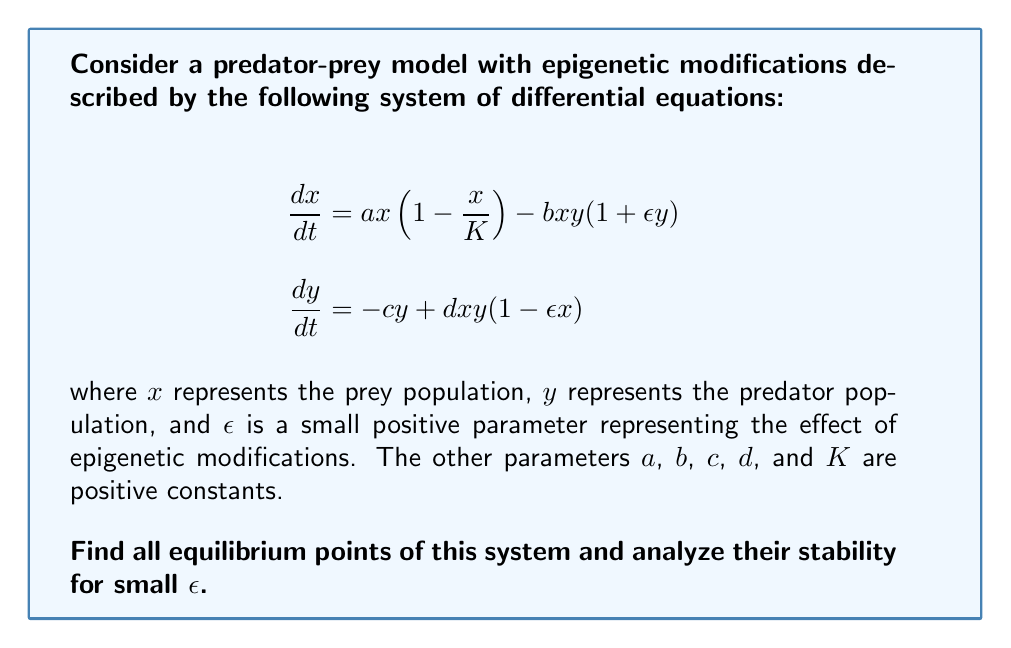Help me with this question. To solve this problem, we'll follow these steps:

1) Find the equilibrium points by setting $\frac{dx}{dt} = 0$ and $\frac{dy}{dt} = 0$.
2) Linearize the system around each equilibrium point.
3) Analyze the stability of each equilibrium point using the Jacobian matrix.

Step 1: Finding equilibrium points

Setting $\frac{dx}{dt} = 0$ and $\frac{dy}{dt} = 0$:

$$\begin{align}
ax(1-\frac{x}{K}) - bxy(1+\epsilon y) &= 0 \tag{1} \\
-cy + dxy(1-\epsilon x) &= 0 \tag{2}
\end{align}$$

From (2), we get:
$y = 0$ or $x = \frac{c}{d(1-\epsilon x)}$

If $y = 0$, from (1) we get:
$x = 0$ or $x = K$

So, two equilibrium points are $(0,0)$ and $(K,0)$.

For the third equilibrium point, substitute $x = \frac{c}{d(1-\epsilon x)}$ into (1):

$$a\frac{c}{d(1-\epsilon x)}(1-\frac{c}{Kd(1-\epsilon x)}) - b\frac{c}{d(1-\epsilon x)}y(1+\epsilon y) = 0$$

Solving this equation along with $x = \frac{c}{d(1-\epsilon x)}$ gives us the third equilibrium point. For small $\epsilon$, we can approximate this point as:

$$(x^*, y^*) \approx (\frac{c}{d}, \frac{a}{b}(1-\frac{c}{Kd}))$$

Step 2: Linearization

The Jacobian matrix for this system is:

$$J = \begin{bmatrix}
a(1-\frac{2x}{K}) - by(1+\epsilon y) & -bx(1+2\epsilon y) \\
dy(1-2\epsilon x) & -c + dx(1-\epsilon x)
\end{bmatrix}$$

Step 3: Stability analysis

For $(0,0)$:
$$J_{(0,0)} = \begin{bmatrix}
a & 0 \\
0 & -c
\end{bmatrix}$$

The eigenvalues are $a$ and $-c$. Since $a > 0$, this point is unstable.

For $(K,0)$:
$$J_{(K,0)} = \begin{bmatrix}
-a & -bK \\
0 & -c+dK
\end{bmatrix}$$

The eigenvalues are $-a$ and $-c+dK$. This point is stable if $dK < c$.

For the third point $(x^*, y^*)$, we substitute the approximate values:

$$J_{(x^*,y^*)} \approx \begin{bmatrix}
-\frac{ac}{Kd} & -\frac{bc}{d} \\
\frac{a}{b}(1-\frac{c}{Kd}) & 0
\end{bmatrix}$$

The characteristic equation is:

$$\lambda^2 + \frac{ac}{Kd}\lambda + \frac{ac}{Kd}(1-\frac{c}{Kd}) = 0$$

For stability, we need both roots to have negative real parts. This is true if $\frac{ac}{Kd} > 0$ (which it is) and $\frac{ac}{Kd}(1-\frac{c}{Kd}) > 0$, which is true if $c < Kd$.
Answer: The system has three equilibrium points:
1) $(0,0)$: unstable
2) $(K,0)$: stable if $dK < c$
3) $(x^*, y^*) \approx (\frac{c}{d}, \frac{a}{b}(1-\frac{c}{Kd}))$: stable if $c < Kd$

For small $\epsilon$, the stability conditions remain the same as in the classical Lotka-Volterra model, but the exact location of the coexistence equilibrium point $(x^*, y^*)$ is slightly modified by the epigenetic effects. 